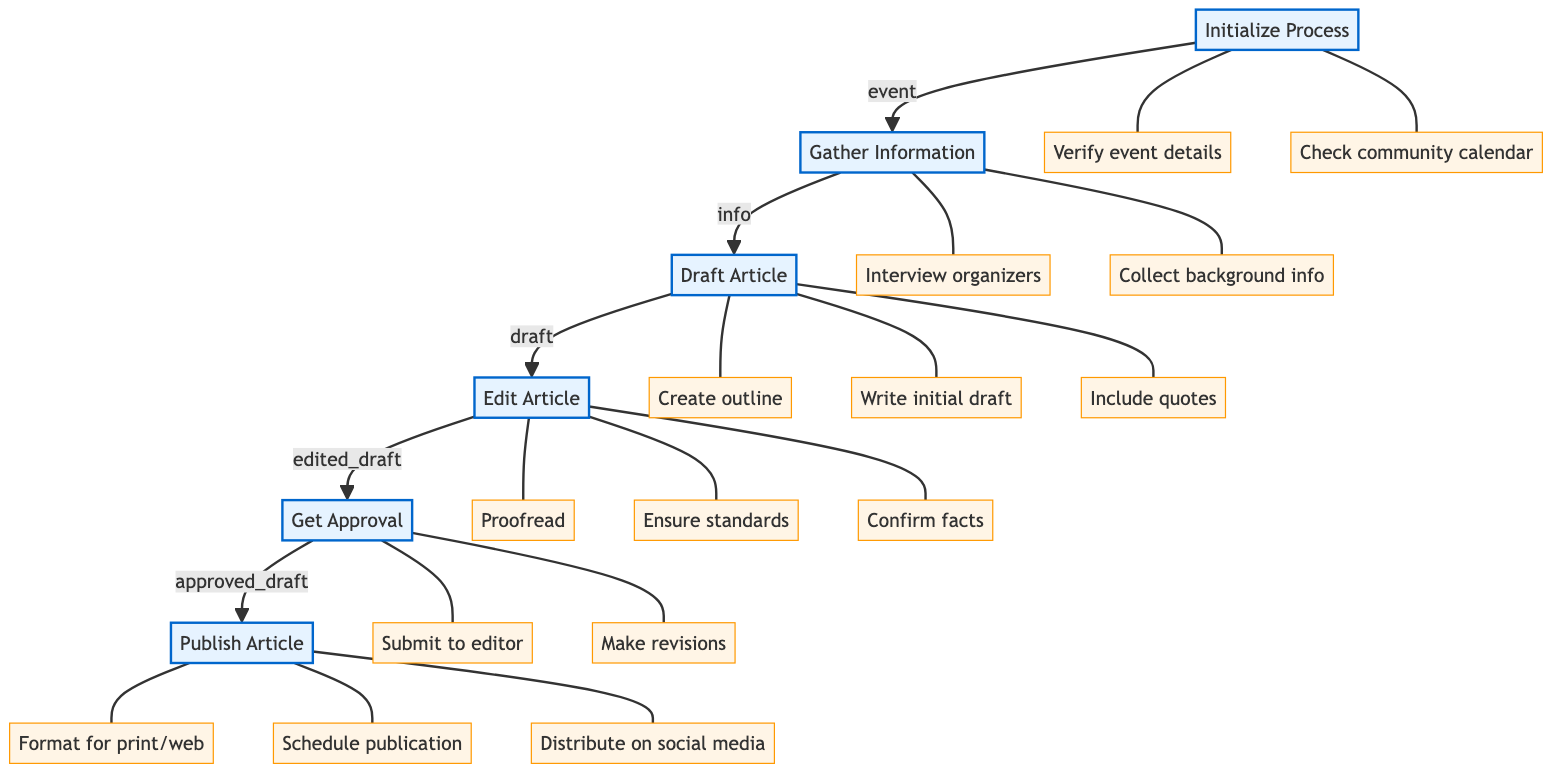What is the first step in the process? The first step in the process, as shown in the flowchart, is "Initialize Process." This step sets the stage for the entire news article publication process.
Answer: Initialize Process How many main steps are there in the diagram? By counting the main steps in the diagram, we observe that there are a total of five steps: Initialize Process, Gather Information, Draft Article, Edit Article, Get Approval, and Publish Article. Thus, there are six main steps.
Answer: Six Which step follows the "Edit Article" step? In the flowchart, after the "Edit Article" step, the next step indicated is "Get Approval." This shows the sequence of steps moving toward final publication.
Answer: Get Approval What tasks are involved in the "Gather Information" step? The tasks listed for the "Gather Information" step in the diagram include two specific actions: "Interview event organizers" and "Collect background information and past event highlights." These tasks focus on obtaining vital information for the article.
Answer: Interview event organizers, Collect background information and past event highlights Which task is associated with the "Get Approval" step? The "Get Approval" step includes two specific tasks: "Submit article to senior editor" and "Make necessary revisions based on feedback." These tasks highlight the editing and approval phase in the article publication process.
Answer: Submit article to senior editor, Make necessary revisions based on feedback What are the last two steps in the process? The last two steps in the flowchart are "Get Approval" and "Publish Article." This indicates that after the article is edited and approved, the final action taken is the publication of the article.
Answer: Get Approval, Publish Article How many tasks are listed under the "Draft Article" step? In the "Draft Article" step, three specific tasks are listed: "Create article outline," "Write initial draft," and "Include quotes from community leaders and event organizers." Therefore, there are three tasks associated with this step.
Answer: Three What tasks need to be completed before publishing the article? Prior to publishing the article, the tasks required are to "Format article for print and web," "Schedule publication date," and "Distribute article through social media channels." These tasks ensure the article is ready for the intended audience.
Answer: Format article for print and web, Schedule publication date, Distribute article through social media channels Which step is a prerequisite to "Draft Article"? The prerequisite step to the "Draft Article" is "Gather Information." This indicates that before drafting the article, information must first be gathered from relevant sources.
Answer: Gather Information 